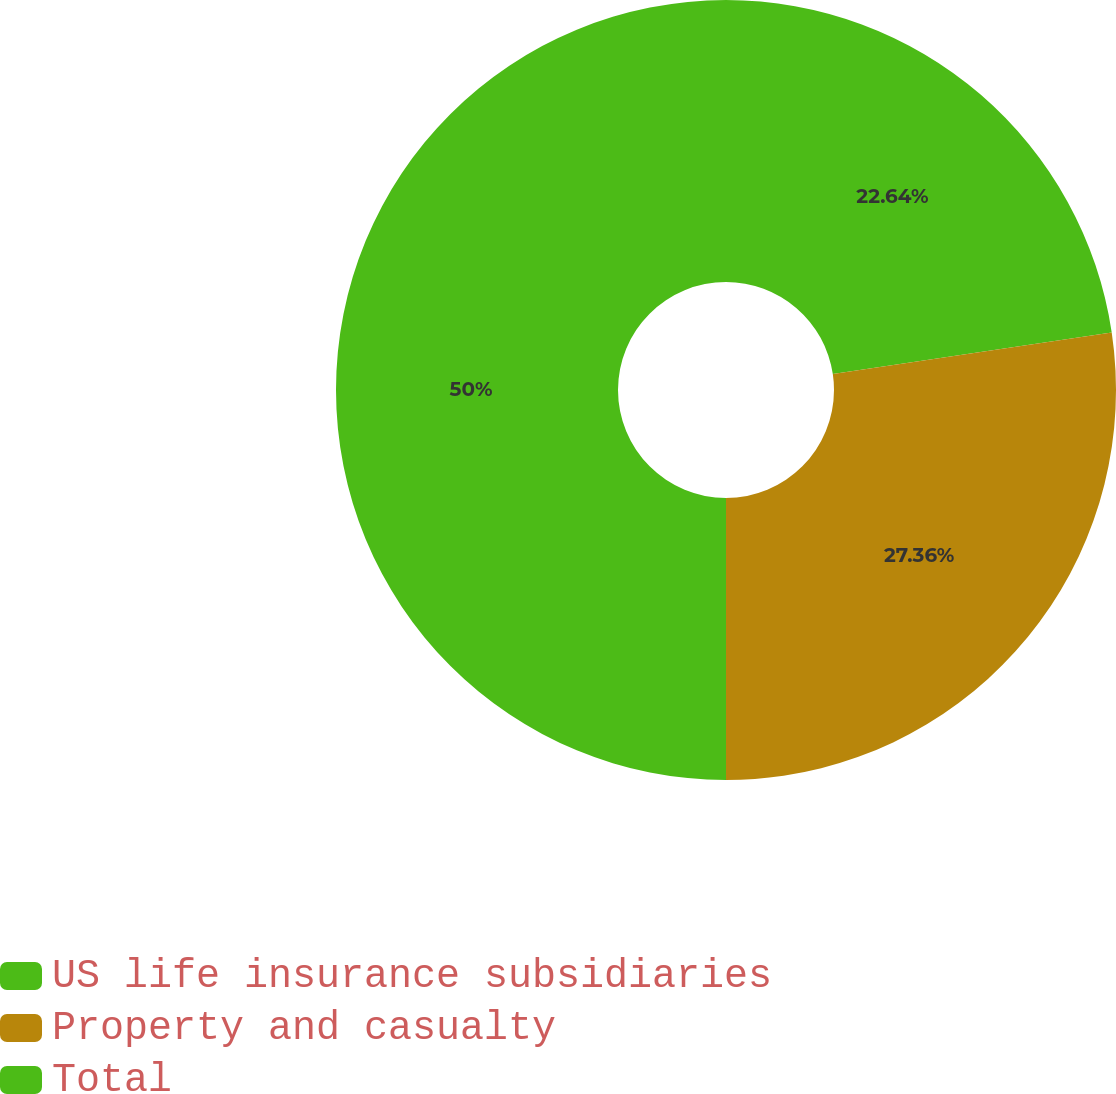Convert chart to OTSL. <chart><loc_0><loc_0><loc_500><loc_500><pie_chart><fcel>US life insurance subsidiaries<fcel>Property and casualty<fcel>Total<nl><fcel>22.64%<fcel>27.36%<fcel>50.0%<nl></chart> 